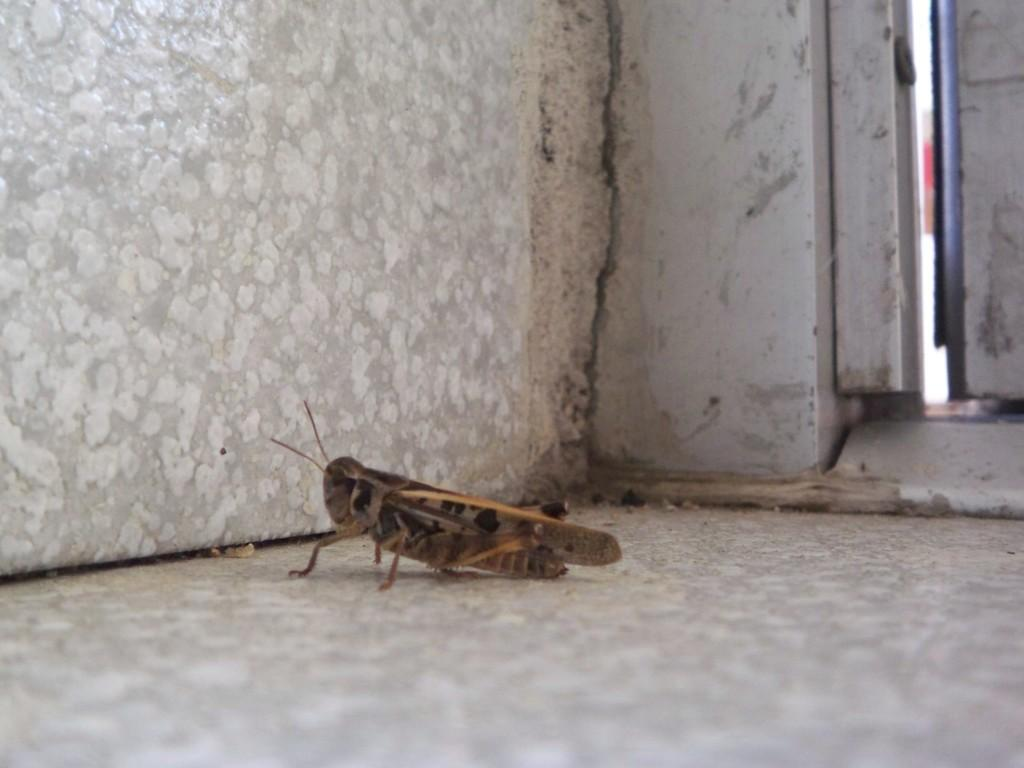What type of insect is present on the surface in the image? There is a grasshopper on the surface in the image. What type of structures can be seen in the image? Walls are visible in the image. What time of day is it in the image, considering the presence of afternoon bushes? There is no mention of afternoon or bushes in the image, so it is not possible to determine the time of day. 